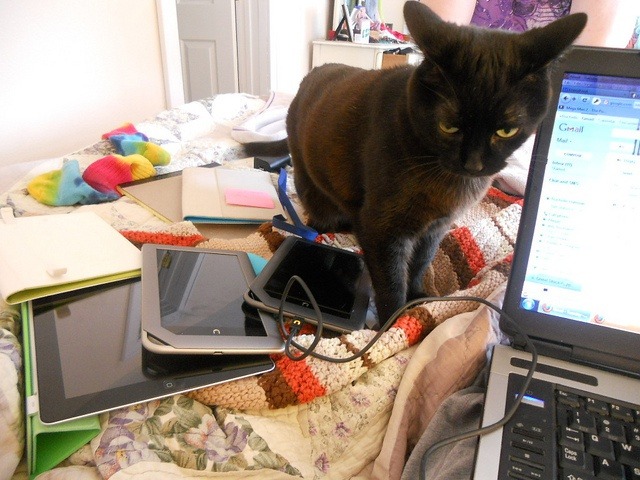Describe the objects in this image and their specific colors. I can see laptop in white, black, gray, and darkgray tones, cat in white, black, maroon, and gray tones, bed in white, tan, and gray tones, laptop in white, gray, and black tones, and keyboard in white, black, and gray tones in this image. 